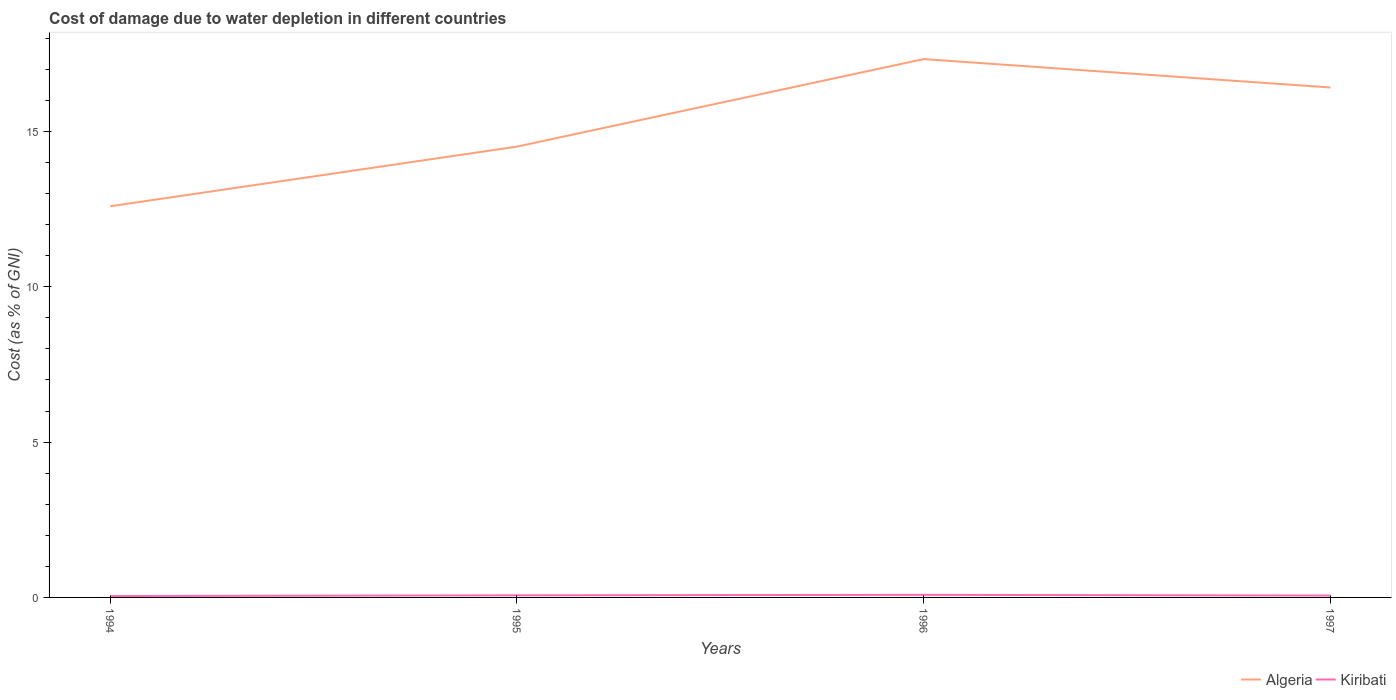How many different coloured lines are there?
Offer a very short reply. 2. Across all years, what is the maximum cost of damage caused due to water depletion in Algeria?
Provide a succinct answer. 12.59. In which year was the cost of damage caused due to water depletion in Kiribati maximum?
Your answer should be compact. 1994. What is the total cost of damage caused due to water depletion in Algeria in the graph?
Provide a short and direct response. -1.92. What is the difference between the highest and the second highest cost of damage caused due to water depletion in Algeria?
Provide a short and direct response. 4.74. Is the cost of damage caused due to water depletion in Kiribati strictly greater than the cost of damage caused due to water depletion in Algeria over the years?
Your answer should be very brief. Yes. Does the graph contain any zero values?
Your response must be concise. No. Does the graph contain grids?
Your answer should be very brief. No. What is the title of the graph?
Provide a succinct answer. Cost of damage due to water depletion in different countries. What is the label or title of the Y-axis?
Your response must be concise. Cost (as % of GNI). What is the Cost (as % of GNI) of Algeria in 1994?
Your response must be concise. 12.59. What is the Cost (as % of GNI) of Kiribati in 1994?
Keep it short and to the point. 0.04. What is the Cost (as % of GNI) in Algeria in 1995?
Your response must be concise. 14.51. What is the Cost (as % of GNI) in Kiribati in 1995?
Offer a very short reply. 0.07. What is the Cost (as % of GNI) of Algeria in 1996?
Provide a short and direct response. 17.33. What is the Cost (as % of GNI) in Kiribati in 1996?
Give a very brief answer. 0.08. What is the Cost (as % of GNI) in Algeria in 1997?
Provide a succinct answer. 16.41. What is the Cost (as % of GNI) of Kiribati in 1997?
Your response must be concise. 0.06. Across all years, what is the maximum Cost (as % of GNI) of Algeria?
Your response must be concise. 17.33. Across all years, what is the maximum Cost (as % of GNI) in Kiribati?
Your answer should be compact. 0.08. Across all years, what is the minimum Cost (as % of GNI) of Algeria?
Your answer should be very brief. 12.59. Across all years, what is the minimum Cost (as % of GNI) in Kiribati?
Give a very brief answer. 0.04. What is the total Cost (as % of GNI) of Algeria in the graph?
Your answer should be compact. 60.85. What is the total Cost (as % of GNI) in Kiribati in the graph?
Give a very brief answer. 0.26. What is the difference between the Cost (as % of GNI) of Algeria in 1994 and that in 1995?
Your response must be concise. -1.92. What is the difference between the Cost (as % of GNI) of Kiribati in 1994 and that in 1995?
Your answer should be compact. -0.02. What is the difference between the Cost (as % of GNI) in Algeria in 1994 and that in 1996?
Provide a succinct answer. -4.74. What is the difference between the Cost (as % of GNI) in Kiribati in 1994 and that in 1996?
Provide a short and direct response. -0.04. What is the difference between the Cost (as % of GNI) of Algeria in 1994 and that in 1997?
Provide a short and direct response. -3.82. What is the difference between the Cost (as % of GNI) in Kiribati in 1994 and that in 1997?
Ensure brevity in your answer.  -0.01. What is the difference between the Cost (as % of GNI) in Algeria in 1995 and that in 1996?
Provide a short and direct response. -2.82. What is the difference between the Cost (as % of GNI) of Kiribati in 1995 and that in 1996?
Your answer should be very brief. -0.02. What is the difference between the Cost (as % of GNI) in Algeria in 1995 and that in 1997?
Ensure brevity in your answer.  -1.9. What is the difference between the Cost (as % of GNI) of Kiribati in 1995 and that in 1997?
Ensure brevity in your answer.  0.01. What is the difference between the Cost (as % of GNI) in Algeria in 1996 and that in 1997?
Provide a short and direct response. 0.91. What is the difference between the Cost (as % of GNI) of Kiribati in 1996 and that in 1997?
Keep it short and to the point. 0.02. What is the difference between the Cost (as % of GNI) in Algeria in 1994 and the Cost (as % of GNI) in Kiribati in 1995?
Keep it short and to the point. 12.52. What is the difference between the Cost (as % of GNI) in Algeria in 1994 and the Cost (as % of GNI) in Kiribati in 1996?
Your answer should be compact. 12.51. What is the difference between the Cost (as % of GNI) in Algeria in 1994 and the Cost (as % of GNI) in Kiribati in 1997?
Provide a succinct answer. 12.53. What is the difference between the Cost (as % of GNI) of Algeria in 1995 and the Cost (as % of GNI) of Kiribati in 1996?
Provide a succinct answer. 14.43. What is the difference between the Cost (as % of GNI) of Algeria in 1995 and the Cost (as % of GNI) of Kiribati in 1997?
Your answer should be compact. 14.45. What is the difference between the Cost (as % of GNI) of Algeria in 1996 and the Cost (as % of GNI) of Kiribati in 1997?
Your answer should be very brief. 17.27. What is the average Cost (as % of GNI) of Algeria per year?
Offer a very short reply. 15.21. What is the average Cost (as % of GNI) in Kiribati per year?
Offer a very short reply. 0.06. In the year 1994, what is the difference between the Cost (as % of GNI) in Algeria and Cost (as % of GNI) in Kiribati?
Your answer should be very brief. 12.55. In the year 1995, what is the difference between the Cost (as % of GNI) in Algeria and Cost (as % of GNI) in Kiribati?
Offer a very short reply. 14.44. In the year 1996, what is the difference between the Cost (as % of GNI) of Algeria and Cost (as % of GNI) of Kiribati?
Provide a short and direct response. 17.25. In the year 1997, what is the difference between the Cost (as % of GNI) in Algeria and Cost (as % of GNI) in Kiribati?
Your response must be concise. 16.35. What is the ratio of the Cost (as % of GNI) of Algeria in 1994 to that in 1995?
Ensure brevity in your answer.  0.87. What is the ratio of the Cost (as % of GNI) in Kiribati in 1994 to that in 1995?
Your answer should be compact. 0.66. What is the ratio of the Cost (as % of GNI) in Algeria in 1994 to that in 1996?
Offer a very short reply. 0.73. What is the ratio of the Cost (as % of GNI) in Kiribati in 1994 to that in 1996?
Your response must be concise. 0.54. What is the ratio of the Cost (as % of GNI) of Algeria in 1994 to that in 1997?
Give a very brief answer. 0.77. What is the ratio of the Cost (as % of GNI) of Kiribati in 1994 to that in 1997?
Give a very brief answer. 0.75. What is the ratio of the Cost (as % of GNI) of Algeria in 1995 to that in 1996?
Your answer should be very brief. 0.84. What is the ratio of the Cost (as % of GNI) in Kiribati in 1995 to that in 1996?
Offer a terse response. 0.81. What is the ratio of the Cost (as % of GNI) in Algeria in 1995 to that in 1997?
Ensure brevity in your answer.  0.88. What is the ratio of the Cost (as % of GNI) of Kiribati in 1995 to that in 1997?
Keep it short and to the point. 1.13. What is the ratio of the Cost (as % of GNI) of Algeria in 1996 to that in 1997?
Offer a terse response. 1.06. What is the ratio of the Cost (as % of GNI) of Kiribati in 1996 to that in 1997?
Your response must be concise. 1.39. What is the difference between the highest and the second highest Cost (as % of GNI) in Algeria?
Offer a very short reply. 0.91. What is the difference between the highest and the second highest Cost (as % of GNI) of Kiribati?
Provide a short and direct response. 0.02. What is the difference between the highest and the lowest Cost (as % of GNI) in Algeria?
Ensure brevity in your answer.  4.74. What is the difference between the highest and the lowest Cost (as % of GNI) of Kiribati?
Give a very brief answer. 0.04. 